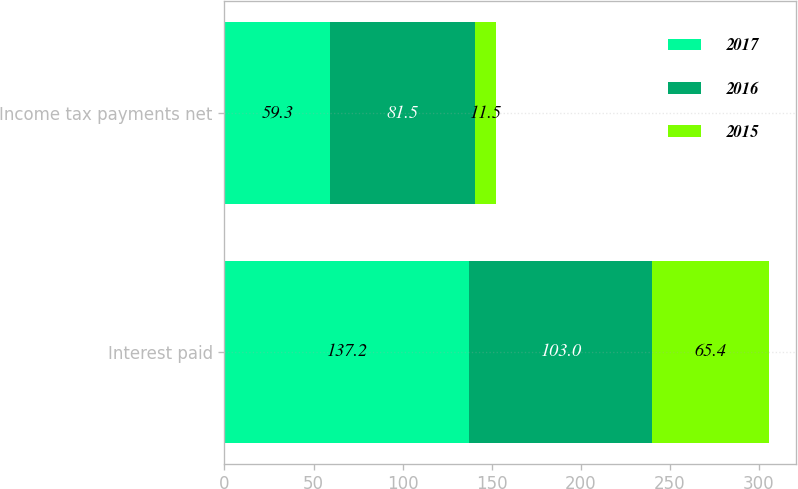Convert chart. <chart><loc_0><loc_0><loc_500><loc_500><stacked_bar_chart><ecel><fcel>Interest paid<fcel>Income tax payments net<nl><fcel>2017<fcel>137.2<fcel>59.3<nl><fcel>2016<fcel>103<fcel>81.5<nl><fcel>2015<fcel>65.4<fcel>11.5<nl></chart> 